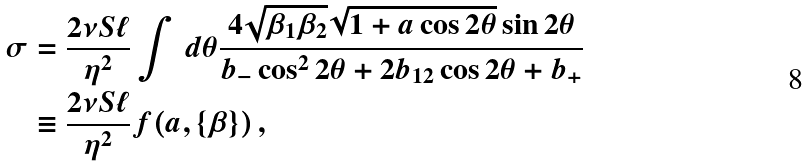Convert formula to latex. <formula><loc_0><loc_0><loc_500><loc_500>\sigma & = \frac { 2 \nu S \ell } { \eta ^ { 2 } } \int \, d \theta \frac { 4 \sqrt { \beta _ { 1 } \beta _ { 2 } } \sqrt { 1 + a \cos 2 \theta } \sin 2 \theta } { b _ { - } \cos ^ { 2 } 2 \theta + 2 b _ { 1 2 } \cos 2 \theta + b _ { + } } \\ & \equiv \frac { 2 \nu S \ell } { \eta ^ { 2 } } f ( a , \{ \beta \} ) \, ,</formula> 